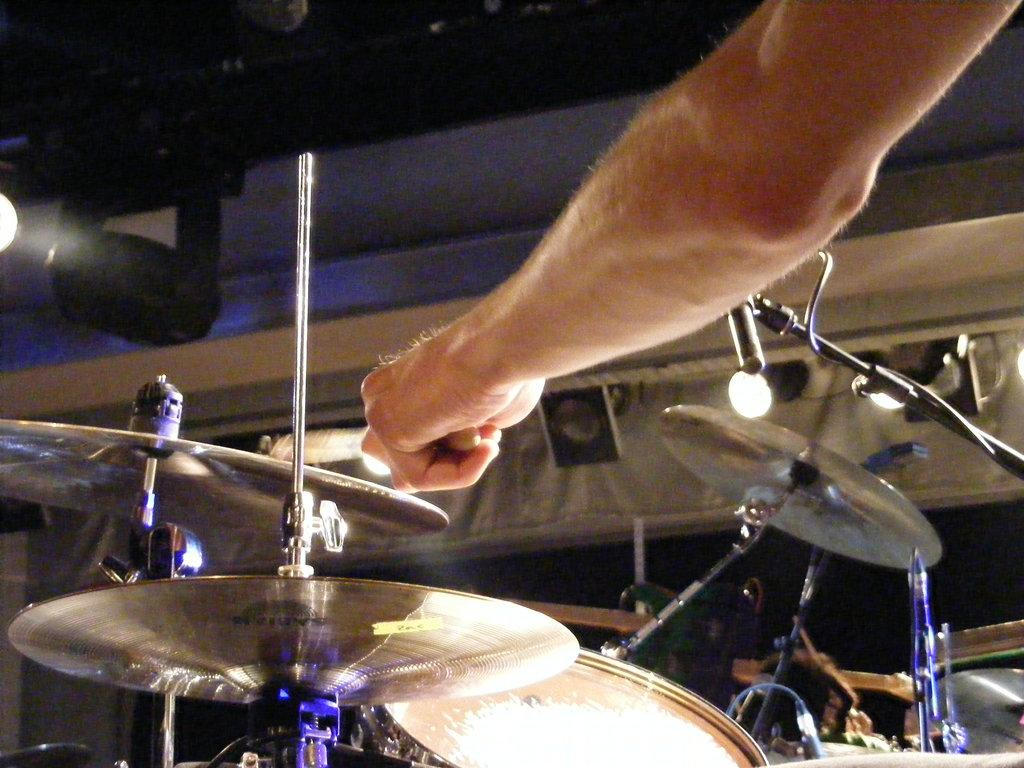What is the main object in the center of the image? There is a drum set in the center of the image. Can you describe anything in the top right side of the image? There is a hand in the top right side of the image. What is located on the left side of the image? There is a spotlight on the left side of the image. Are there any fairies visible in the image? No, there are no fairies present in the image. What type of board is being used by the hand in the image? There is no board visible in the image; only a hand, a drum set, and a spotlight are present. 